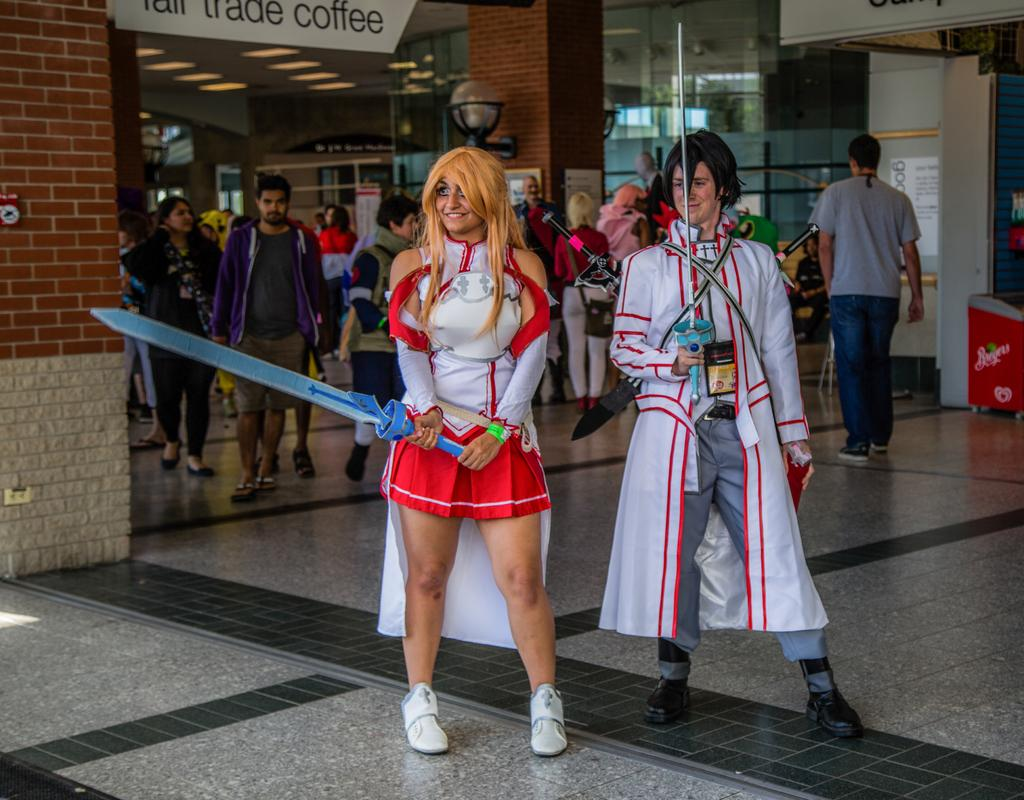<image>
Offer a succinct explanation of the picture presented. A man and woman are dressed in a costumes with swords and standing under a sign that says Fair Trade Coffee. 